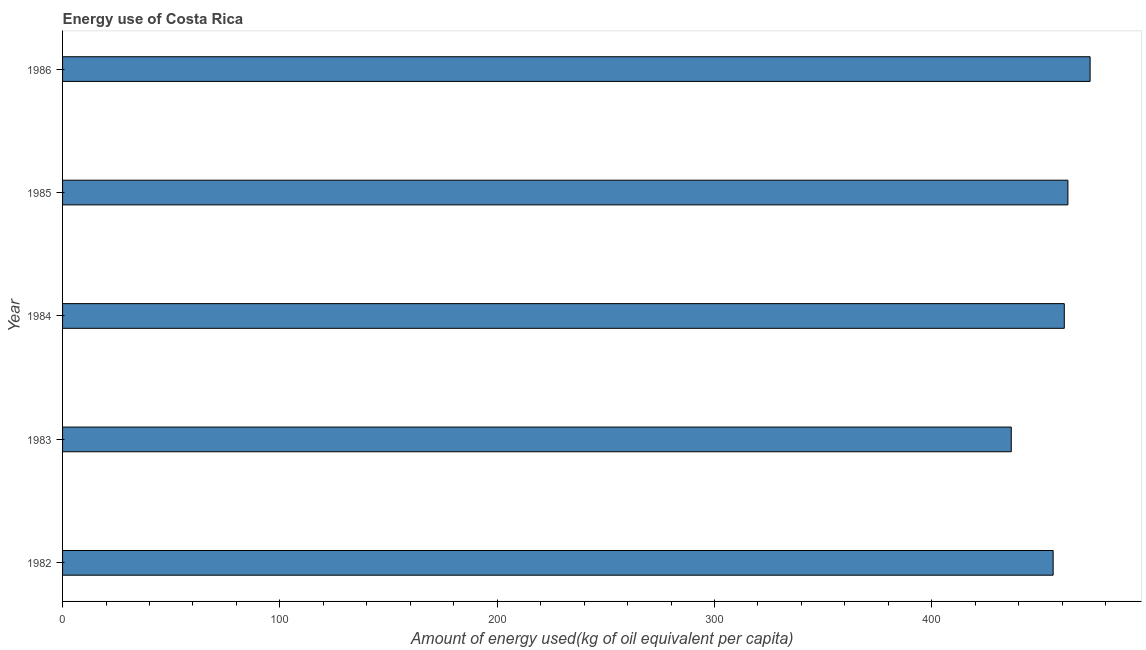Does the graph contain any zero values?
Keep it short and to the point. No. What is the title of the graph?
Give a very brief answer. Energy use of Costa Rica. What is the label or title of the X-axis?
Make the answer very short. Amount of energy used(kg of oil equivalent per capita). What is the amount of energy used in 1984?
Provide a succinct answer. 460.95. Across all years, what is the maximum amount of energy used?
Ensure brevity in your answer.  472.83. Across all years, what is the minimum amount of energy used?
Ensure brevity in your answer.  436.55. In which year was the amount of energy used maximum?
Provide a short and direct response. 1986. In which year was the amount of energy used minimum?
Your answer should be compact. 1983. What is the sum of the amount of energy used?
Give a very brief answer. 2288.78. What is the difference between the amount of energy used in 1982 and 1984?
Give a very brief answer. -5.13. What is the average amount of energy used per year?
Give a very brief answer. 457.75. What is the median amount of energy used?
Make the answer very short. 460.95. In how many years, is the amount of energy used greater than 20 kg?
Give a very brief answer. 5. What is the ratio of the amount of energy used in 1982 to that in 1984?
Your response must be concise. 0.99. What is the difference between the highest and the second highest amount of energy used?
Offer a very short reply. 10.22. What is the difference between the highest and the lowest amount of energy used?
Offer a terse response. 36.28. How many bars are there?
Your response must be concise. 5. Are all the bars in the graph horizontal?
Ensure brevity in your answer.  Yes. Are the values on the major ticks of X-axis written in scientific E-notation?
Give a very brief answer. No. What is the Amount of energy used(kg of oil equivalent per capita) of 1982?
Your answer should be very brief. 455.82. What is the Amount of energy used(kg of oil equivalent per capita) in 1983?
Offer a very short reply. 436.55. What is the Amount of energy used(kg of oil equivalent per capita) of 1984?
Give a very brief answer. 460.95. What is the Amount of energy used(kg of oil equivalent per capita) in 1985?
Your response must be concise. 462.62. What is the Amount of energy used(kg of oil equivalent per capita) in 1986?
Your response must be concise. 472.83. What is the difference between the Amount of energy used(kg of oil equivalent per capita) in 1982 and 1983?
Your response must be concise. 19.27. What is the difference between the Amount of energy used(kg of oil equivalent per capita) in 1982 and 1984?
Your answer should be very brief. -5.13. What is the difference between the Amount of energy used(kg of oil equivalent per capita) in 1982 and 1985?
Give a very brief answer. -6.79. What is the difference between the Amount of energy used(kg of oil equivalent per capita) in 1982 and 1986?
Your response must be concise. -17.01. What is the difference between the Amount of energy used(kg of oil equivalent per capita) in 1983 and 1984?
Your answer should be very brief. -24.4. What is the difference between the Amount of energy used(kg of oil equivalent per capita) in 1983 and 1985?
Your response must be concise. -26.06. What is the difference between the Amount of energy used(kg of oil equivalent per capita) in 1983 and 1986?
Ensure brevity in your answer.  -36.28. What is the difference between the Amount of energy used(kg of oil equivalent per capita) in 1984 and 1985?
Keep it short and to the point. -1.67. What is the difference between the Amount of energy used(kg of oil equivalent per capita) in 1984 and 1986?
Offer a very short reply. -11.88. What is the difference between the Amount of energy used(kg of oil equivalent per capita) in 1985 and 1986?
Keep it short and to the point. -10.22. What is the ratio of the Amount of energy used(kg of oil equivalent per capita) in 1982 to that in 1983?
Your answer should be compact. 1.04. What is the ratio of the Amount of energy used(kg of oil equivalent per capita) in 1982 to that in 1984?
Provide a succinct answer. 0.99. What is the ratio of the Amount of energy used(kg of oil equivalent per capita) in 1983 to that in 1984?
Your answer should be compact. 0.95. What is the ratio of the Amount of energy used(kg of oil equivalent per capita) in 1983 to that in 1985?
Offer a terse response. 0.94. What is the ratio of the Amount of energy used(kg of oil equivalent per capita) in 1983 to that in 1986?
Give a very brief answer. 0.92. What is the ratio of the Amount of energy used(kg of oil equivalent per capita) in 1984 to that in 1986?
Ensure brevity in your answer.  0.97. 